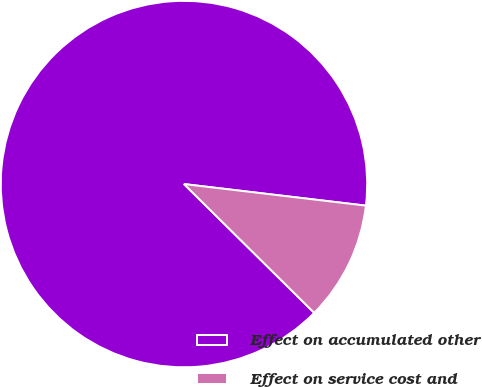Convert chart. <chart><loc_0><loc_0><loc_500><loc_500><pie_chart><fcel>Effect on accumulated other<fcel>Effect on service cost and<nl><fcel>89.47%<fcel>10.53%<nl></chart> 